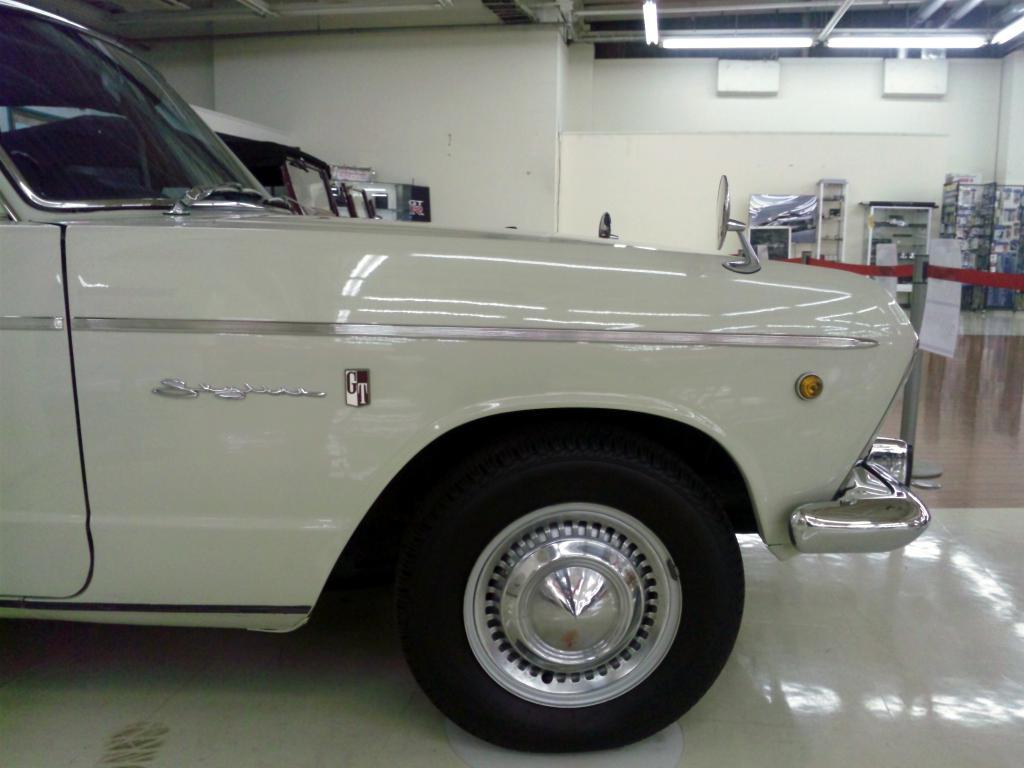What can be seen on the floor in the image? There are two cars on the floor in the image. What is visible in the background of the image? There is a wall, lights, and a cupboard in the background of the image. Are there any other objects on the floor in the background of the image? Yes, there are other objects on the floor in the background of the image. What type of location might the image have been taken in? The image may have been taken in a showroom. What type of collar is visible on the cars in the image? There are no collars present on the cars in the image; they are vehicles, not animals. 